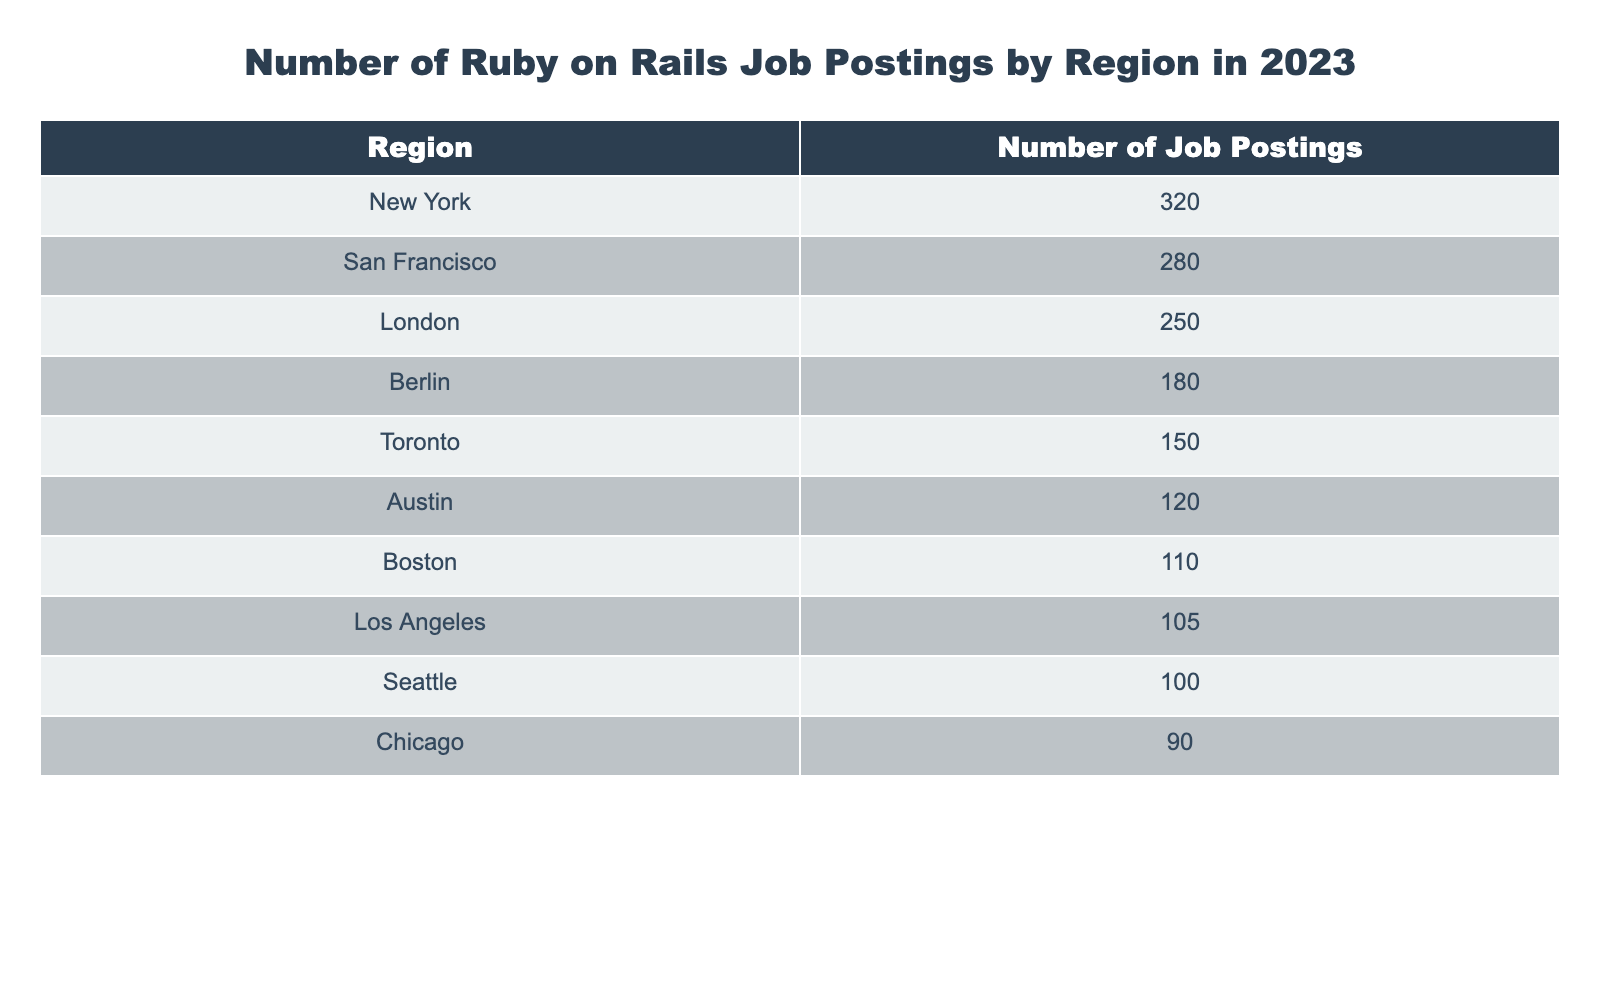What region has the highest number of Ruby on Rails job postings? By examining the table, we can see the values listed for each region. The highest number of job postings is 320, which corresponds to New York.
Answer: New York What is the total number of Ruby on Rails job postings in the top three regions? The top three regions are New York (320), San Francisco (280), and London (250). We add these values: 320 + 280 + 250 = 850.
Answer: 850 Is the number of job postings in Berlin greater than 150? Referring to the table, Berlin has 180 job postings, which is indeed greater than 150.
Answer: Yes Which region has the least number of job postings? Looking at the table, Chicago has the least number of job postings with a value of 90.
Answer: Chicago What is the average number of job postings across all listed regions? To find the average, we sum all the postings: 320 + 280 + 250 + 180 + 150 + 120 + 110 + 105 + 100 + 90 = 1,705. Since there are 10 regions, we divide this sum by 10: 1,705 / 10 = 170.5.
Answer: 170.5 Are there more job postings in Austin than in Toronto? The table shows Austin has 120 postings and Toronto has 150. Since 120 is less than 150, the answer is no.
Answer: No How many more job postings are there in San Francisco compared to Boston? San Francisco has 280 postings and Boston has 110, so we find the difference: 280 - 110 = 170.
Answer: 170 Is the number of postings in Los Angeles more than the average of the top five regions? The top five regions are New York (320), San Francisco (280), London (250), Berlin (180), and Toronto (150). First, sum these: 320 + 280 + 250 + 180 + 150 = 1,180. The average is 1,180 / 5 = 236. Los Angeles has 105 postings, which is less than 236.
Answer: No Which two regions have the closest number of job postings? Looking through the numbers, Boston (110) and Los Angeles (105) have the closest values, with a difference of just 5.
Answer: Boston and Los Angeles 